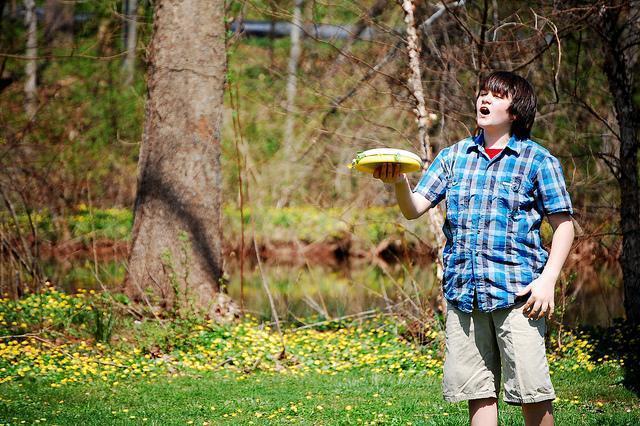How many red color pizza on the bowl?
Give a very brief answer. 0. 